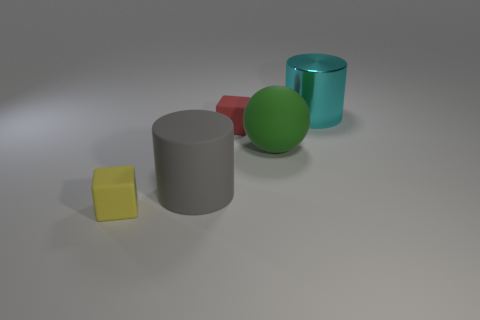Is there any other thing that has the same material as the large cyan cylinder?
Give a very brief answer. No. How many other objects are there of the same size as the green object?
Make the answer very short. 2. What number of objects are large matte things behind the gray rubber thing or big things that are to the right of the rubber sphere?
Give a very brief answer. 2. What number of other small rubber things are the same shape as the small yellow rubber thing?
Provide a short and direct response. 1. There is a object that is both to the right of the red rubber block and in front of the red rubber object; what is it made of?
Make the answer very short. Rubber. How many big cyan metallic objects are on the right side of the gray thing?
Make the answer very short. 1. How many small metallic cubes are there?
Provide a succinct answer. 0. Do the red thing and the yellow rubber block have the same size?
Provide a succinct answer. Yes. Are there any yellow objects on the left side of the large matte thing to the right of the big cylinder in front of the large metal object?
Offer a very short reply. Yes. There is another small thing that is the same shape as the red thing; what is it made of?
Ensure brevity in your answer.  Rubber. 